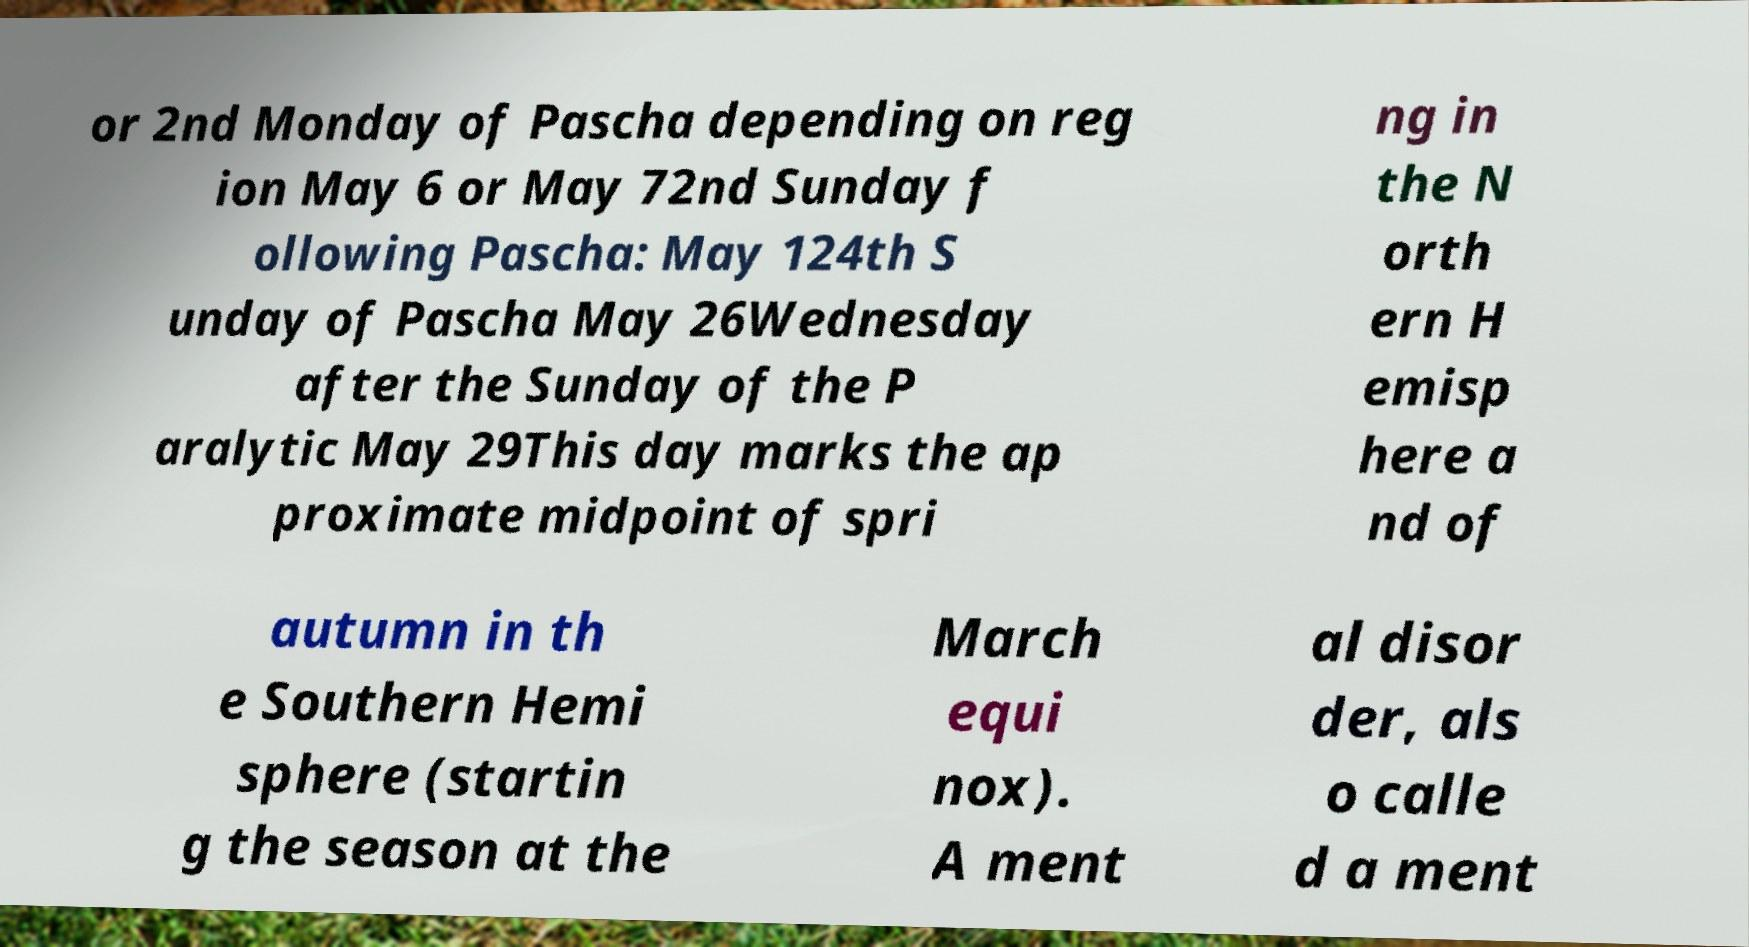Can you read and provide the text displayed in the image?This photo seems to have some interesting text. Can you extract and type it out for me? or 2nd Monday of Pascha depending on reg ion May 6 or May 72nd Sunday f ollowing Pascha: May 124th S unday of Pascha May 26Wednesday after the Sunday of the P aralytic May 29This day marks the ap proximate midpoint of spri ng in the N orth ern H emisp here a nd of autumn in th e Southern Hemi sphere (startin g the season at the March equi nox). A ment al disor der, als o calle d a ment 